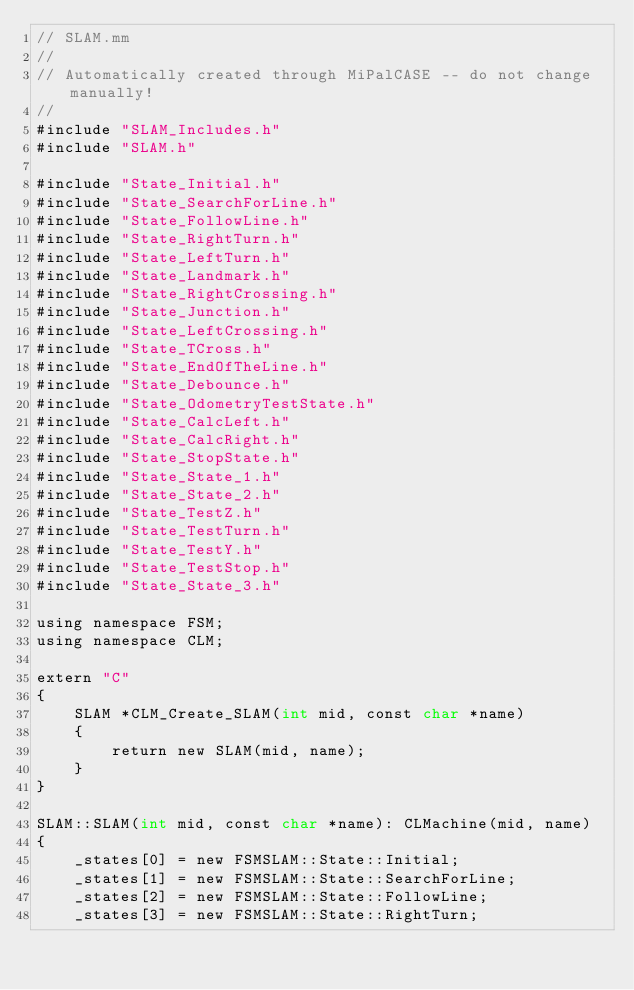<code> <loc_0><loc_0><loc_500><loc_500><_ObjectiveC_>// SLAM.mm
//
// Automatically created through MiPalCASE -- do not change manually!
//
#include "SLAM_Includes.h"
#include "SLAM.h"

#include "State_Initial.h"
#include "State_SearchForLine.h"
#include "State_FollowLine.h"
#include "State_RightTurn.h"
#include "State_LeftTurn.h"
#include "State_Landmark.h"
#include "State_RightCrossing.h"
#include "State_Junction.h"
#include "State_LeftCrossing.h"
#include "State_TCross.h"
#include "State_EndOfTheLine.h"
#include "State_Debounce.h"
#include "State_OdometryTestState.h"
#include "State_CalcLeft.h"
#include "State_CalcRight.h"
#include "State_StopState.h"
#include "State_State_1.h"
#include "State_State_2.h"
#include "State_TestZ.h"
#include "State_TestTurn.h"
#include "State_TestY.h"
#include "State_TestStop.h"
#include "State_State_3.h"

using namespace FSM;
using namespace CLM;

extern "C"
{
	SLAM *CLM_Create_SLAM(int mid, const char *name)
	{
		return new SLAM(mid, name);
	}
}

SLAM::SLAM(int mid, const char *name): CLMachine(mid, name)
{
	_states[0] = new FSMSLAM::State::Initial;
	_states[1] = new FSMSLAM::State::SearchForLine;
	_states[2] = new FSMSLAM::State::FollowLine;
	_states[3] = new FSMSLAM::State::RightTurn;</code> 